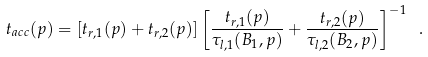<formula> <loc_0><loc_0><loc_500><loc_500>t _ { a c c } ( p ) = \left [ t _ { r , 1 } ( p ) + t _ { r , 2 } ( p ) \right ] \left [ { \frac { t _ { r , 1 } ( p ) } { \tau _ { l , 1 } ( B _ { 1 } , p ) } } + { \frac { t _ { r , 2 } ( p ) } { \tau _ { l , 2 } ( B _ { 2 } , p ) } } \right ] ^ { - 1 } \ .</formula> 